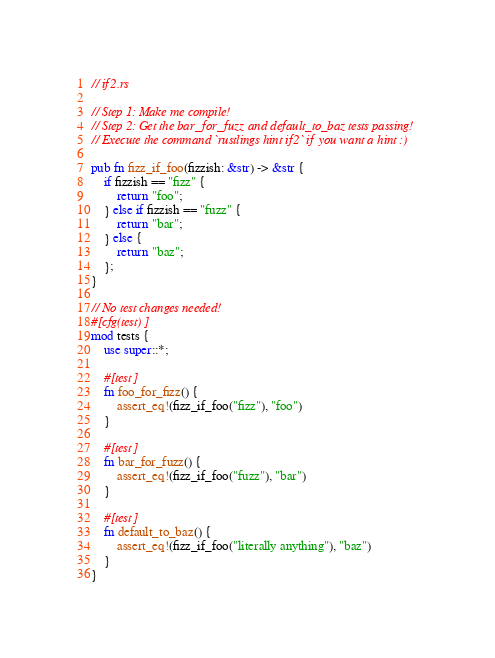<code> <loc_0><loc_0><loc_500><loc_500><_Rust_>// if2.rs

// Step 1: Make me compile!
// Step 2: Get the bar_for_fuzz and default_to_baz tests passing!
// Execute the command `rustlings hint if2` if you want a hint :)

pub fn fizz_if_foo(fizzish: &str) -> &str {
    if fizzish == "fizz" {
        return "foo";
    } else if fizzish == "fuzz" {
        return "bar";
    } else {
        return "baz";
    };
}

// No test changes needed!
#[cfg(test)]
mod tests {
    use super::*;

    #[test]
    fn foo_for_fizz() {
        assert_eq!(fizz_if_foo("fizz"), "foo")
    }

    #[test]
    fn bar_for_fuzz() {
        assert_eq!(fizz_if_foo("fuzz"), "bar")
    }

    #[test]
    fn default_to_baz() {
        assert_eq!(fizz_if_foo("literally anything"), "baz")
    }
}
</code> 